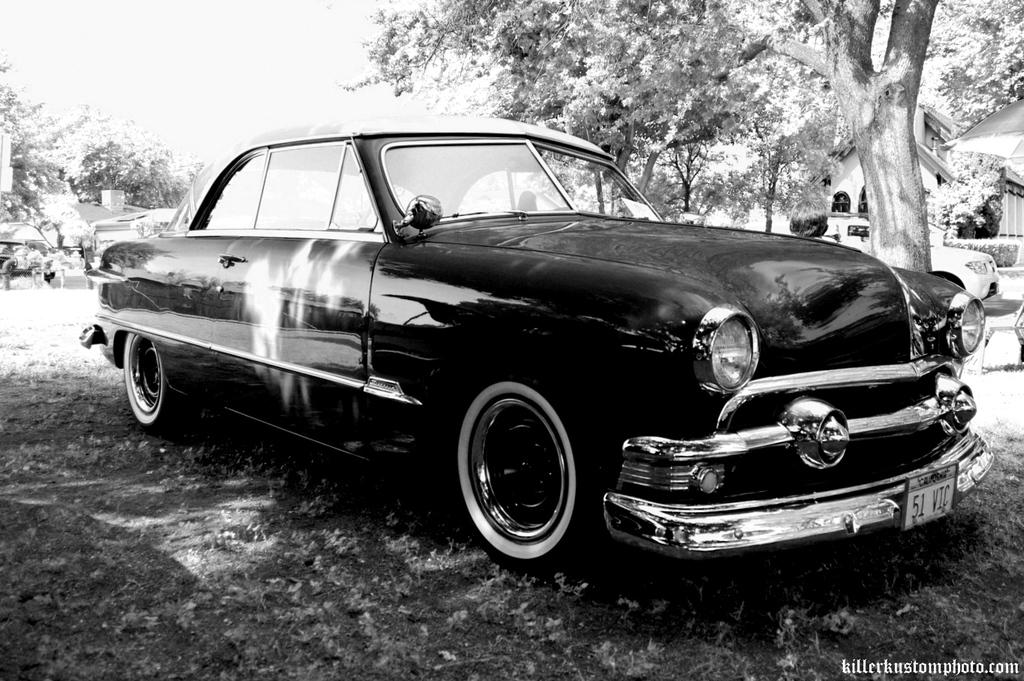What is the main subject of the image? The main subject of the image is a car. Can you describe the surface on which the car is located? The car is on a surface in the image. What can be seen in the background of the image? There are trees, a house, and plants in the background of the image. What type of juice is being served in the car in the image? There is no juice or any indication of a beverage being served in the car in the image. Can you describe the wall that surrounds the car in the image? There is no wall surrounding the car in the image; it is on a surface with a background that includes trees, a house, and plants. 